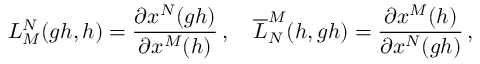Convert formula to latex. <formula><loc_0><loc_0><loc_500><loc_500>L _ { M } ^ { N } ( g h , h ) = \frac { \partial x ^ { N } ( g h ) } { \partial x ^ { M } ( h ) } \, , \quad \overline { L } _ { N } ^ { M } ( h , g h ) = \frac { \partial x ^ { M } ( h ) } { \partial x ^ { N } ( g h ) } \, ,</formula> 